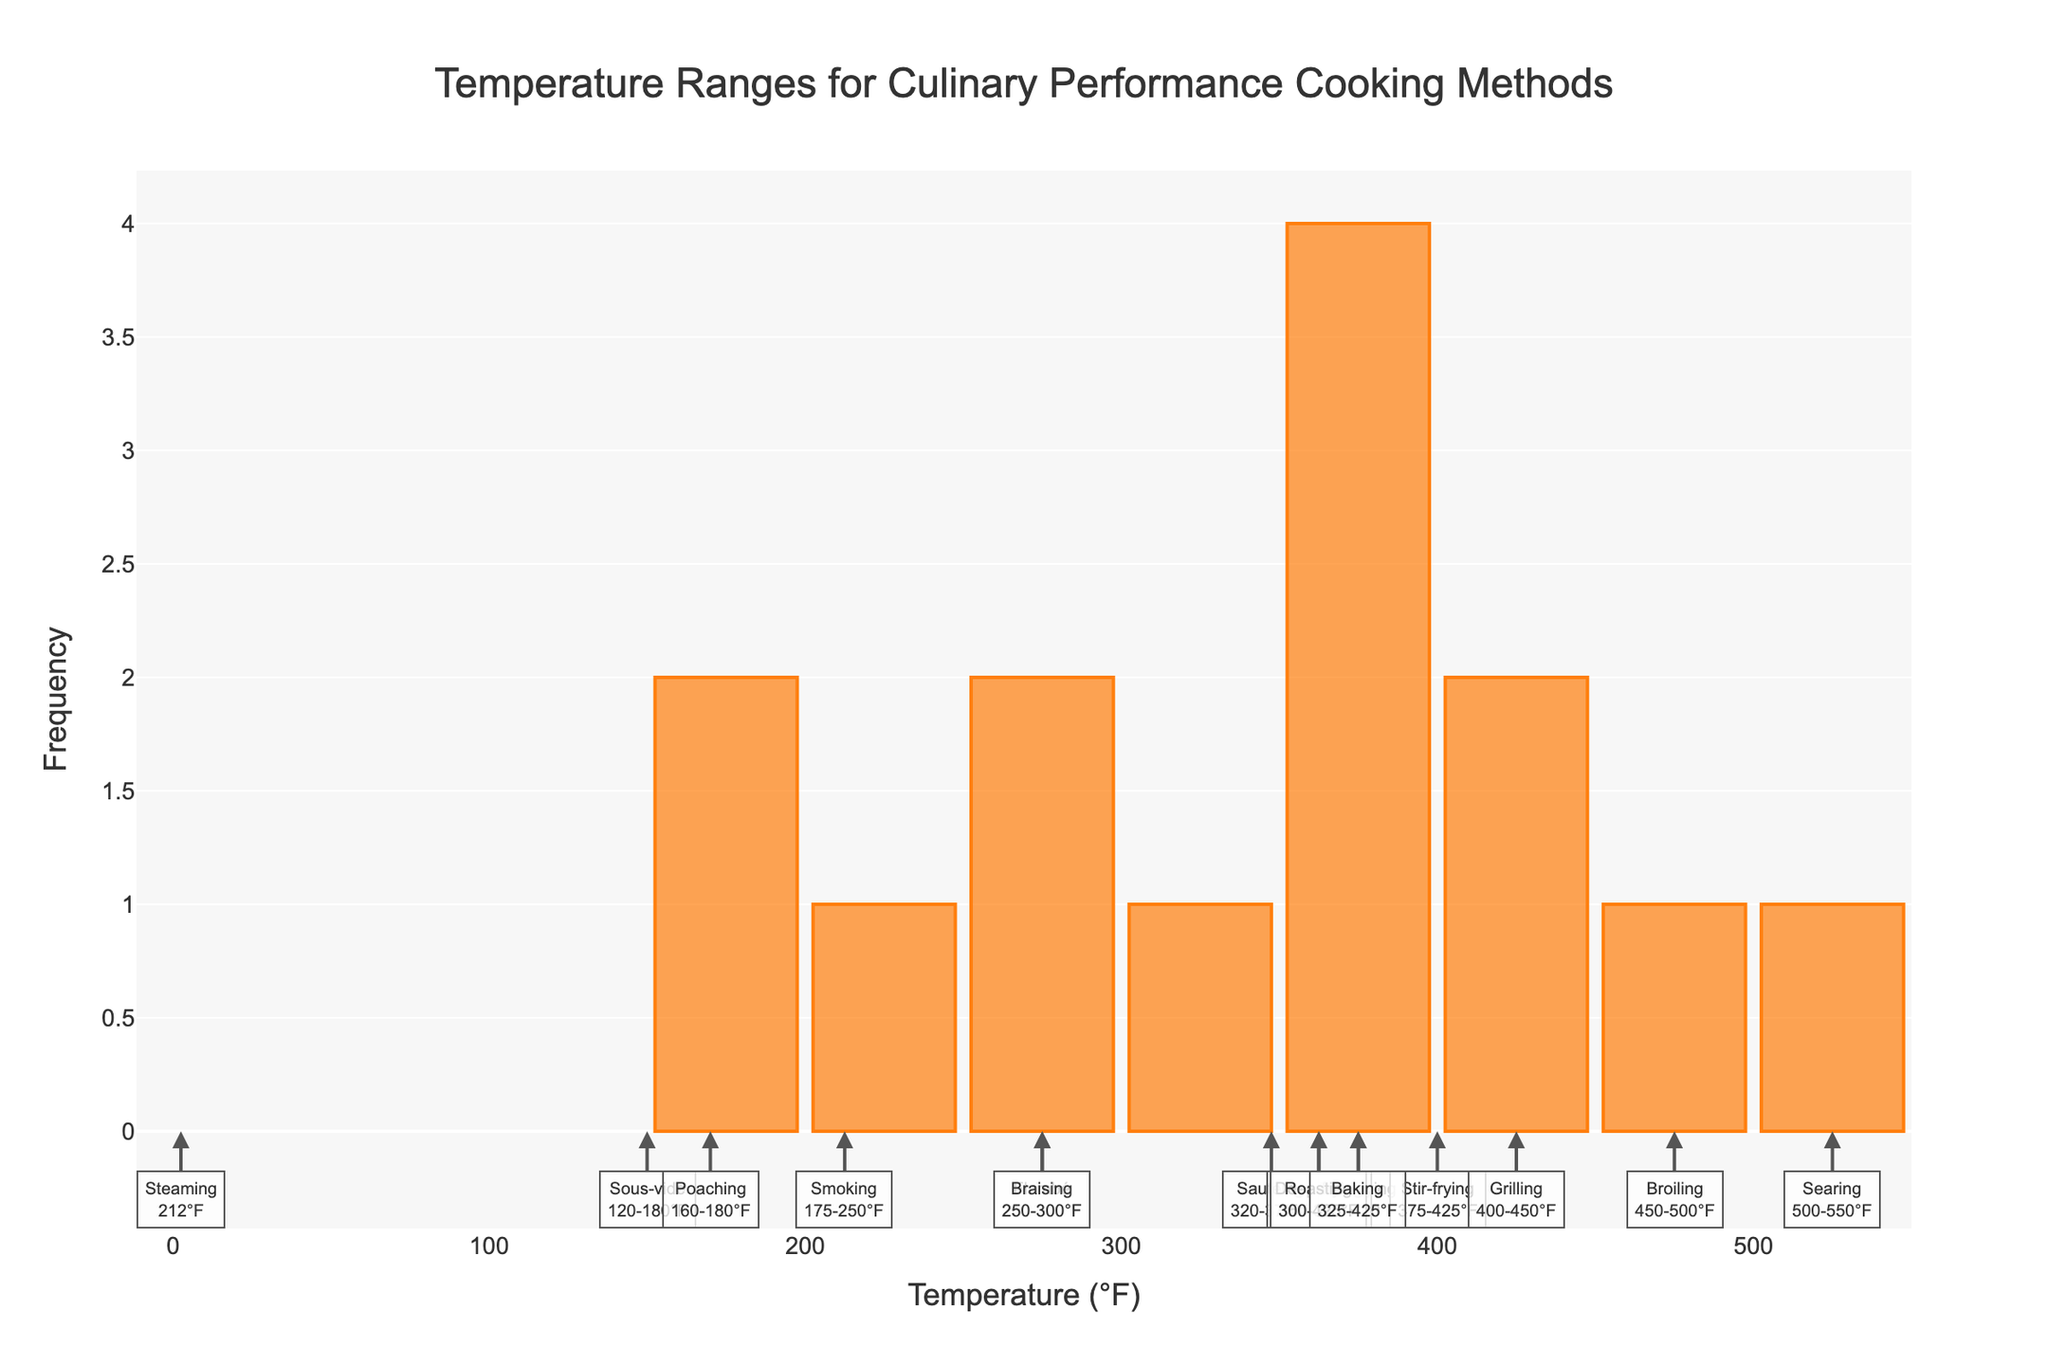What is the title of the histogram? The title is displayed at the top center of the plot and reads "Temperature Ranges for Culinary Performance Cooking Methods".
Answer: Temperature Ranges for Culinary Performance Cooking Methods What is the temperature range with the highest number of occurrences in the histogram? By analyzing the bars in the histogram, the range with the highest frequency can be identified. The range between 350°F and 400°F has the highest number of cooking methods.
Answer: 350-400°F Which cooking method has the lowest temperature range, and what is that range? By looking at the x-axis annotations, the cooking method "Sous-vide" is at the lowest position. Its temperature range is 120-180°F.
Answer: Sous-vide, 120-180°F How many cooking methods fall within the temperature range of 300-400°F? By counting the vertical bars within the 300-400°F range on the x-axis, the cooking methods within this range are "Roasting", "Baking", "Deep-frying", "Pan-frying", "Sautéing", and "Braising". This results in six methods.
Answer: Six methods Which cooking method covers the highest temperature range, and what is that range? The cooking method "Searing" is annotated near the highest temperature on the x-axis, at the 500-550°F range.
Answer: Searing, 500-550°F Compare the frequency of cooking methods in the range of 170-225°F to those in the range of 450-525°F. Which range has more occurrences? By examining the bars within the respective ranges, the 170-225°F range includes "Smoking", "Poaching" (partially), and "Sous-vide". The 450-525°F range includes "Broiling" and "Searing". Thus, the 170-225°F range has more occurrences with three methods compared to two.
Answer: 170-225°F range What are the annotated temperature ranges for "Grilling" and "Broiling"? By identifying the annotations linked to "Grilling" and "Broiling" on the plot, "Grilling" has a range of 400-450°F, and "Broiling" has 450-500°F.
Answer: Grilling: 400-450°F, Broiling: 450-500°F How many cooking methods have a temperature range with a mid-point greater than 400°F? Calculating the mid-point of each range (i.e., (Min + Max)/2) and counting those greater than 400°F involve these methods: "Grilling", "Broiling", "Searing", and "Stir-frying". This totals four methods.
Answer: Four methods Which cooking method falls within the most frequently occurring temperature range in the histogram? The most common range (350-400°F) includes "Pan-frying" and "Deep-frying".
Answer: Pan-frying, Deep-frying 